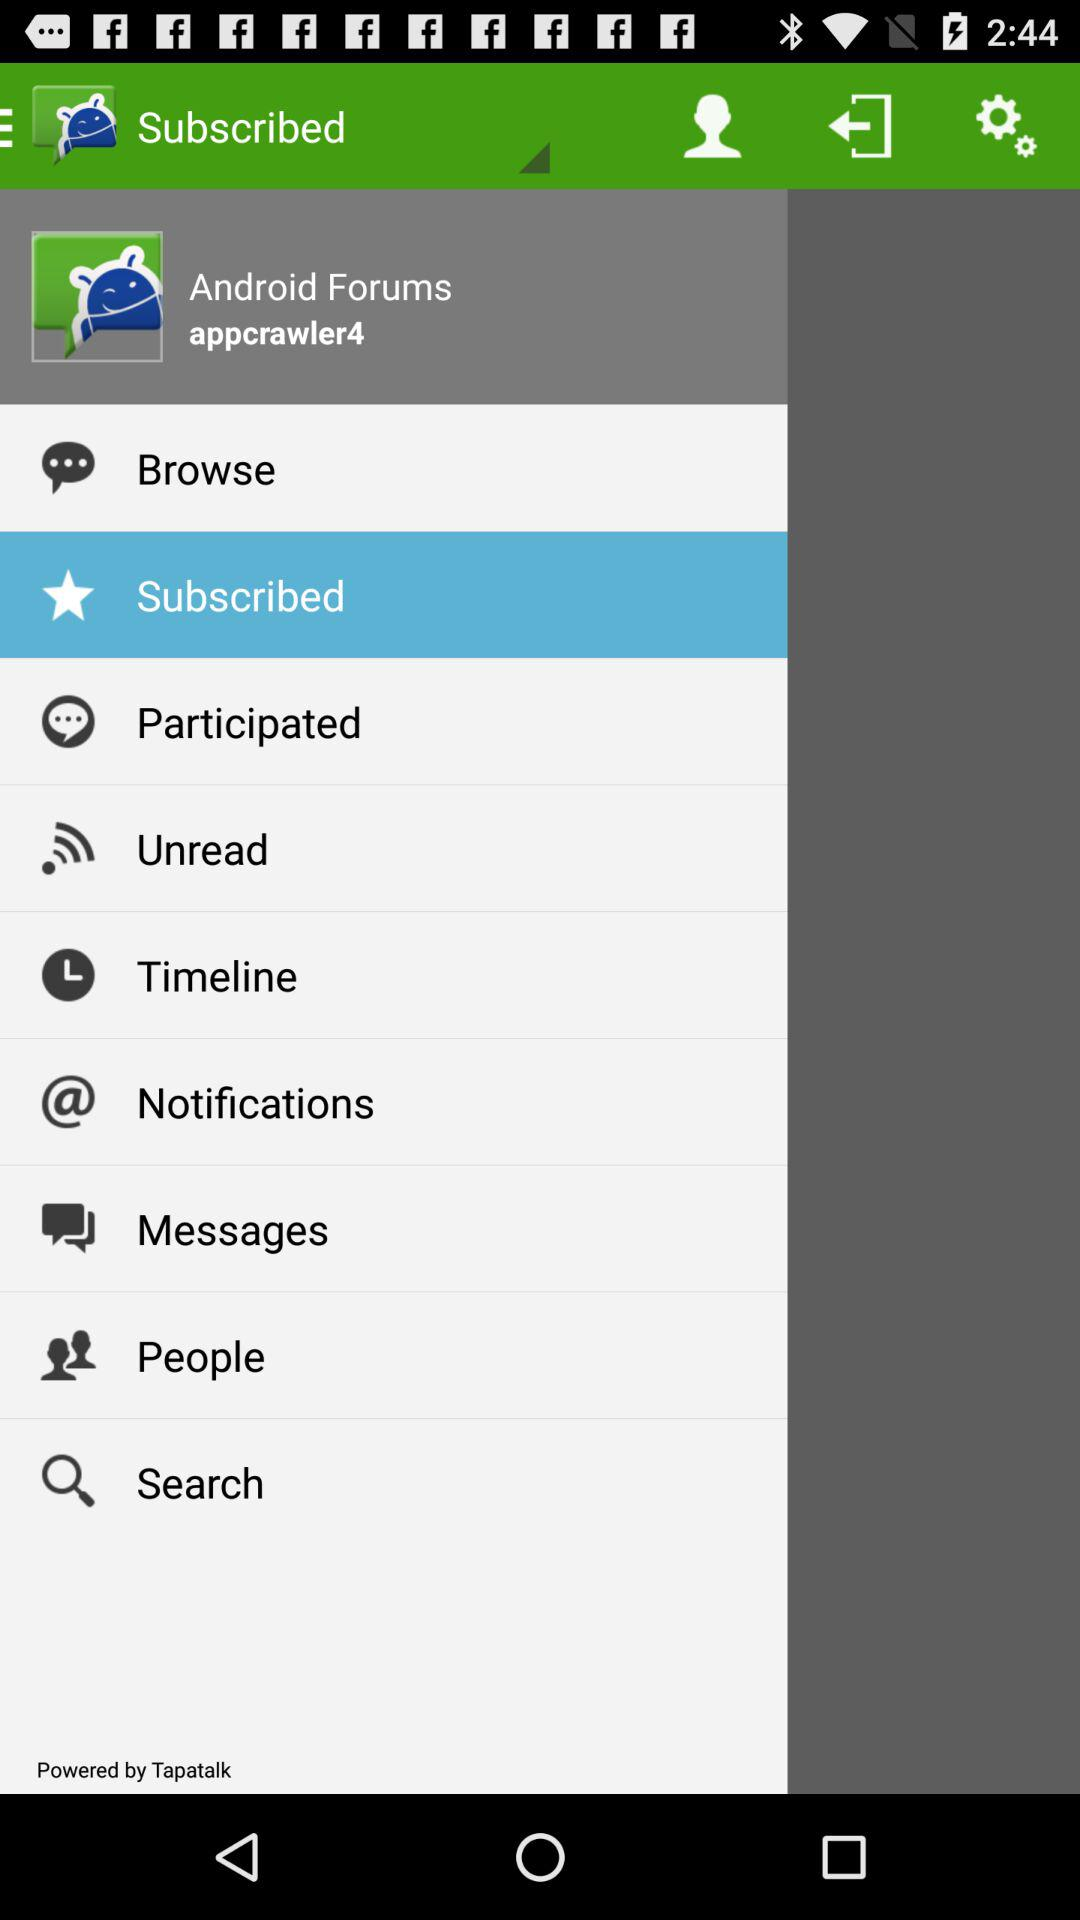What is the username? The username is "appcrawler4". 